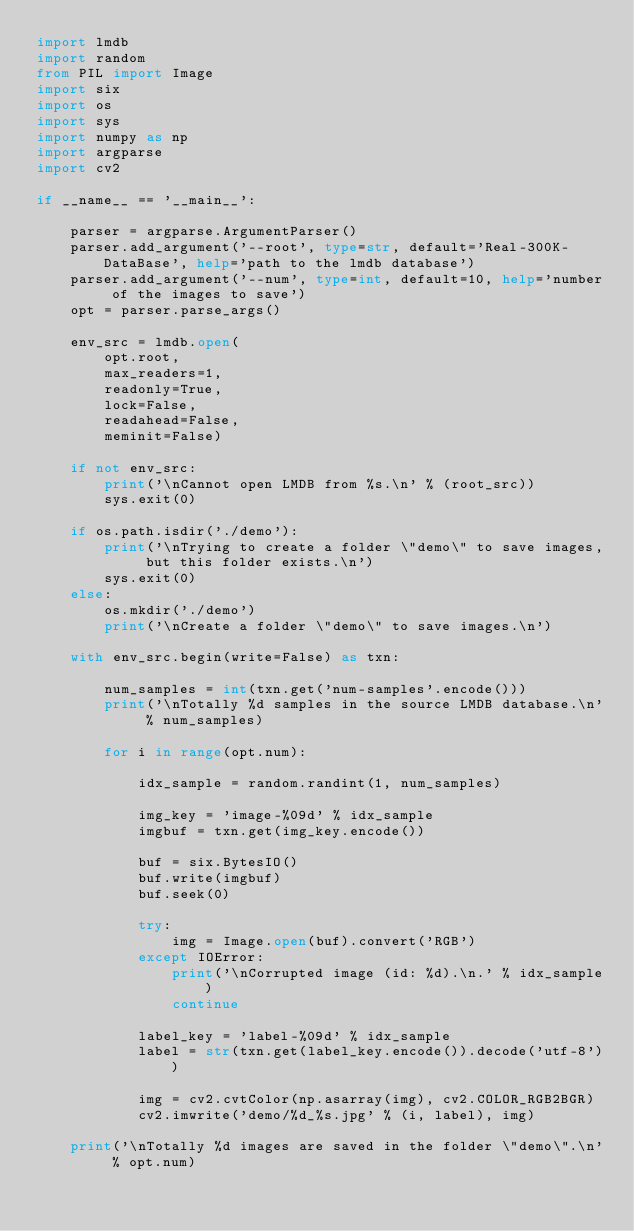Convert code to text. <code><loc_0><loc_0><loc_500><loc_500><_Python_>import lmdb
import random
from PIL import Image
import six
import os
import sys
import numpy as np
import argparse
import cv2

if __name__ == '__main__':

	parser = argparse.ArgumentParser()
	parser.add_argument('--root', type=str, default='Real-300K-DataBase', help='path to the lmdb database')
	parser.add_argument('--num', type=int, default=10, help='number of the images to save')
	opt = parser.parse_args()

	env_src = lmdb.open(
	    opt.root,
	    max_readers=1,
	    readonly=True,
	    lock=False,
	    readahead=False,
	    meminit=False)

	if not env_src:
	    print('\nCannot open LMDB from %s.\n' % (root_src))
	    sys.exit(0)

	if os.path.isdir('./demo'):
		print('\nTrying to create a folder \"demo\" to save images, but this folder exists.\n')
		sys.exit(0)
	else:
		os.mkdir('./demo')
		print('\nCreate a folder \"demo\" to save images.\n')

	with env_src.begin(write=False) as txn:

		num_samples = int(txn.get('num-samples'.encode()))
		print('\nTotally %d samples in the source LMDB database.\n' % num_samples)

		for i in range(opt.num):

			idx_sample = random.randint(1, num_samples)

			img_key = 'image-%09d' % idx_sample
			imgbuf = txn.get(img_key.encode())

			buf = six.BytesIO()
			buf.write(imgbuf)
			buf.seek(0)

			try:
				img = Image.open(buf).convert('RGB')
			except IOError:
				print('\nCorrupted image (id: %d).\n.' % idx_sample)
				continue

			label_key = 'label-%09d' % idx_sample
			label = str(txn.get(label_key.encode()).decode('utf-8'))

			img = cv2.cvtColor(np.asarray(img), cv2.COLOR_RGB2BGR)
			cv2.imwrite('demo/%d_%s.jpg' % (i, label), img)

	print('\nTotally %d images are saved in the folder \"demo\".\n' % opt.num)
				</code> 